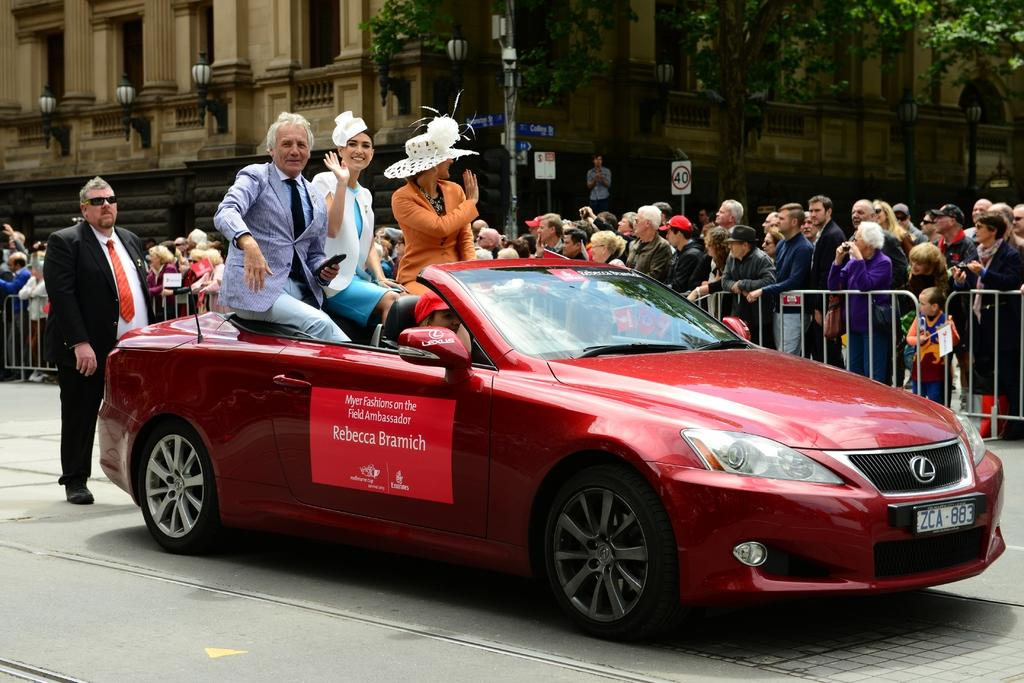What is happening in the image involving the car? There are people in a car on the road. What can be seen alongside the road? There is fencing visible. What are the people near the car doing? There are people standing and watching. What is visible in the background of the image? There is a building and trees in the background. What type of wax is being used by the actor in the image? There is no actor or wax present in the image. How does the anger of the people in the car affect the traffic in the image? There is no indication of anger in the image, and it does not affect the traffic. 